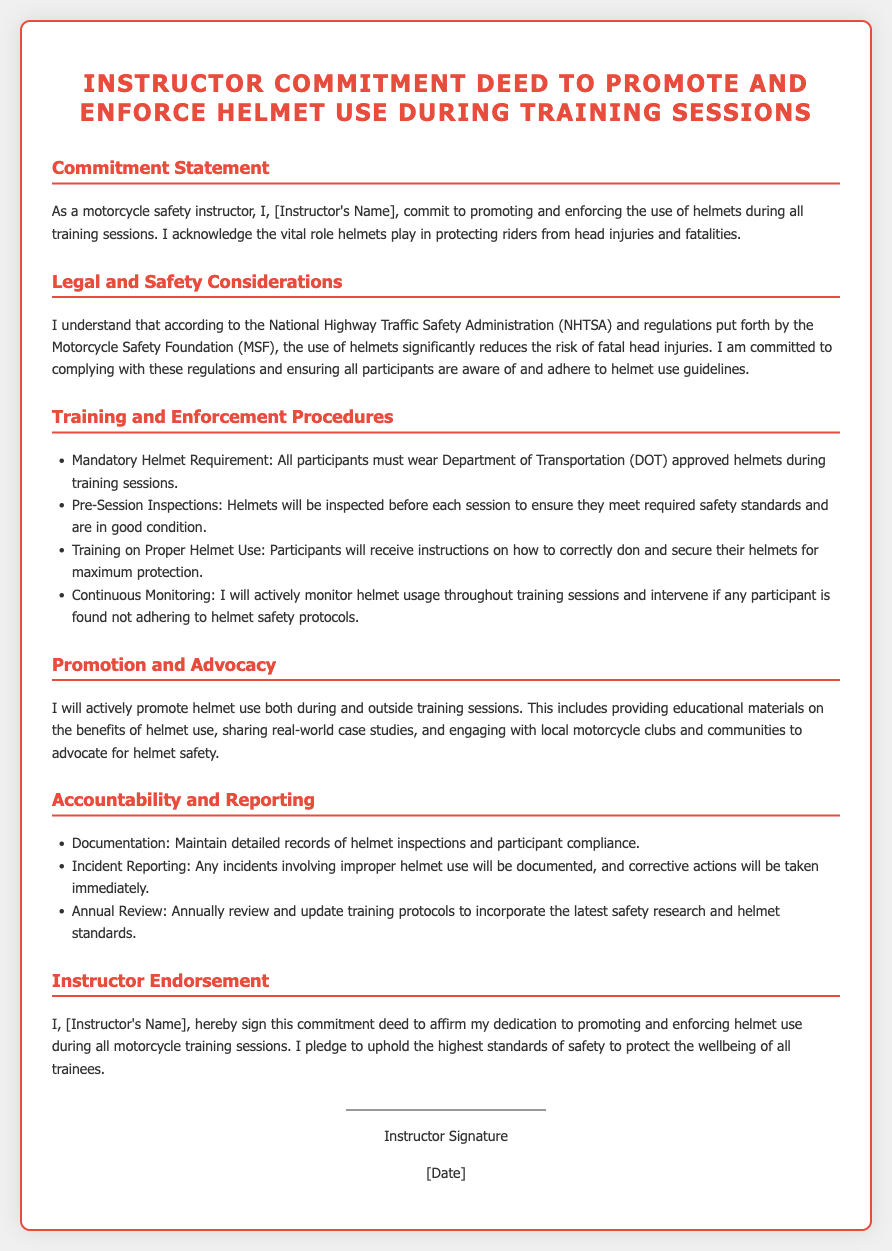What is the title of the document? The title of the document is stated at the beginning, specifying the commitment of the instructor regarding helmet use.
Answer: Instructor Commitment Deed to Promote and Enforce Helmet Use During Training Sessions Who does this commitment deed concern? The commitment deed is specifically concerning the role and responsibilities of an individual educational or training professional.
Answer: Motorcycle safety instructor What is the mandatory helmet requirement for training sessions? The document explicitly states the type of helmets that participants must use during training sessions for compliance.
Answer: Department of Transportation (DOT) approved helmets What type of helmet inspection occurs before each training session? The document outlines the process of ensuring participant safety by checking helmets.
Answer: Pre-Session Inspections Which organization is mentioned as a reference for helmet use regulations? The document references an authoritative organization responsible for traffic safety regulations.
Answer: National Highway Traffic Safety Administration (NHTSA) What will be documented if an improper helmet use incident occurs? The document specifies the action that needs to take place regarding compliance breaches during training.
Answer: Incident Reporting What kind of training will participants receive? The document details the kind of instructional information imparted to participants for their safety.
Answer: Training on Proper Helmet Use What is one method of promoting helmet use outside of training sessions? The document mentions a proactive approach in engaging with community initiatives related to helmet safety advocacy.
Answer: Providing educational materials on the benefits of helmet use 